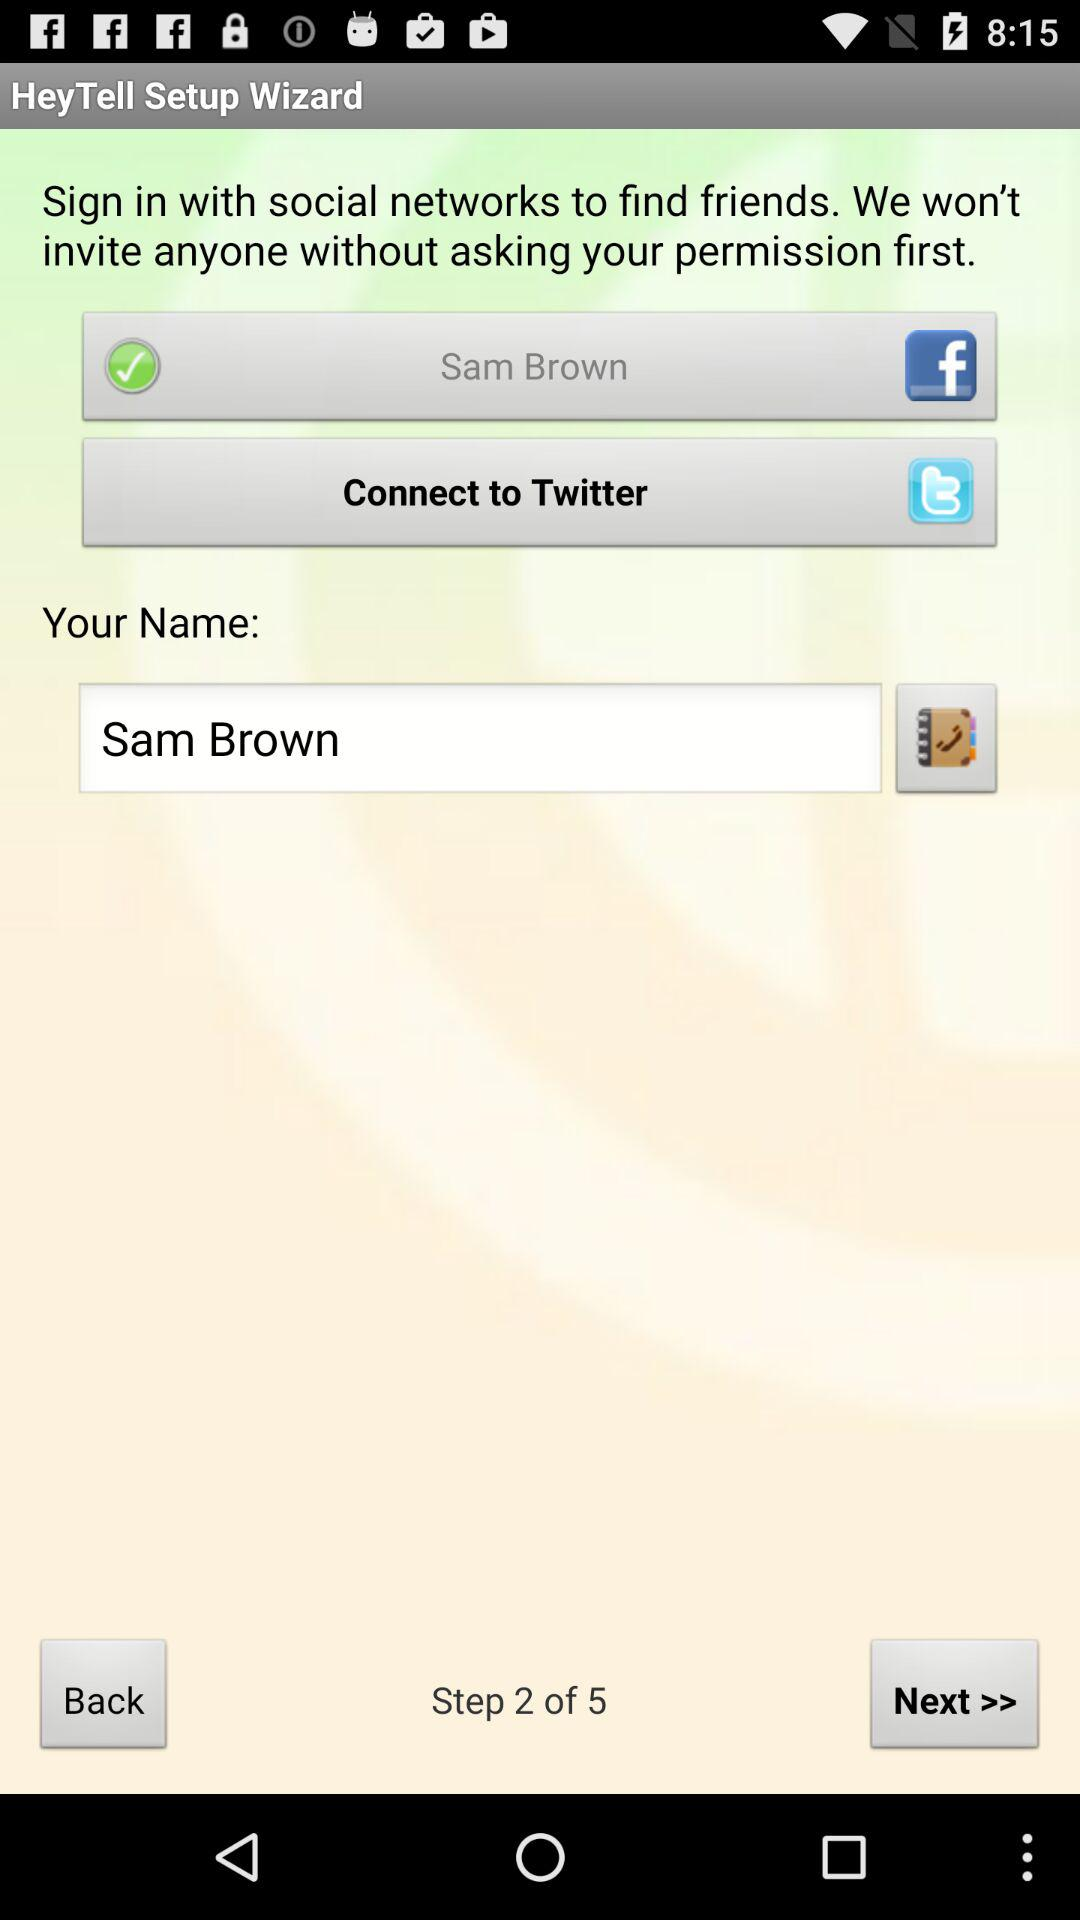What application will ask for permission? The applications are "Facebook" and "Twitter". 